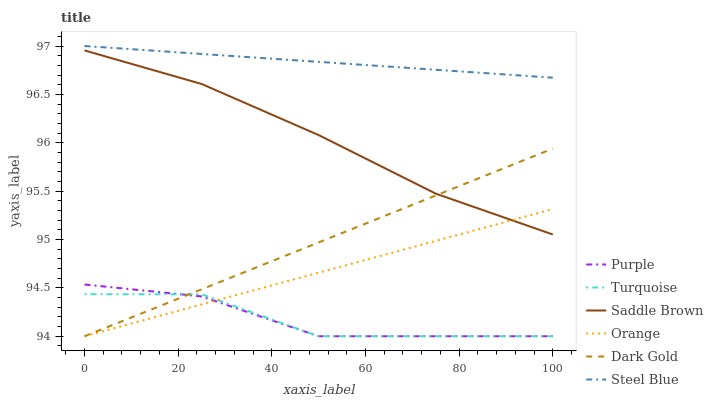Does Turquoise have the minimum area under the curve?
Answer yes or no. Yes. Does Steel Blue have the maximum area under the curve?
Answer yes or no. Yes. Does Dark Gold have the minimum area under the curve?
Answer yes or no. No. Does Dark Gold have the maximum area under the curve?
Answer yes or no. No. Is Steel Blue the smoothest?
Answer yes or no. Yes. Is Turquoise the roughest?
Answer yes or no. Yes. Is Dark Gold the smoothest?
Answer yes or no. No. Is Dark Gold the roughest?
Answer yes or no. No. Does Steel Blue have the lowest value?
Answer yes or no. No. Does Steel Blue have the highest value?
Answer yes or no. Yes. Does Dark Gold have the highest value?
Answer yes or no. No. Is Saddle Brown less than Steel Blue?
Answer yes or no. Yes. Is Saddle Brown greater than Turquoise?
Answer yes or no. Yes. Does Saddle Brown intersect Orange?
Answer yes or no. Yes. Is Saddle Brown less than Orange?
Answer yes or no. No. Is Saddle Brown greater than Orange?
Answer yes or no. No. Does Saddle Brown intersect Steel Blue?
Answer yes or no. No. 